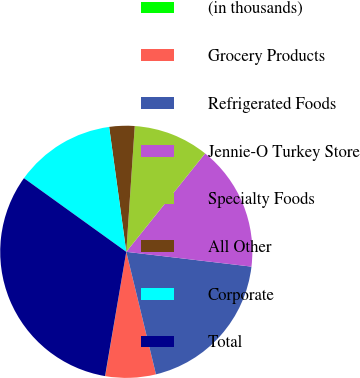Convert chart. <chart><loc_0><loc_0><loc_500><loc_500><pie_chart><fcel>(in thousands)<fcel>Grocery Products<fcel>Refrigerated Foods<fcel>Jennie-O Turkey Store<fcel>Specialty Foods<fcel>All Other<fcel>Corporate<fcel>Total<nl><fcel>0.02%<fcel>6.46%<fcel>19.34%<fcel>16.12%<fcel>9.68%<fcel>3.24%<fcel>12.9%<fcel>32.23%<nl></chart> 